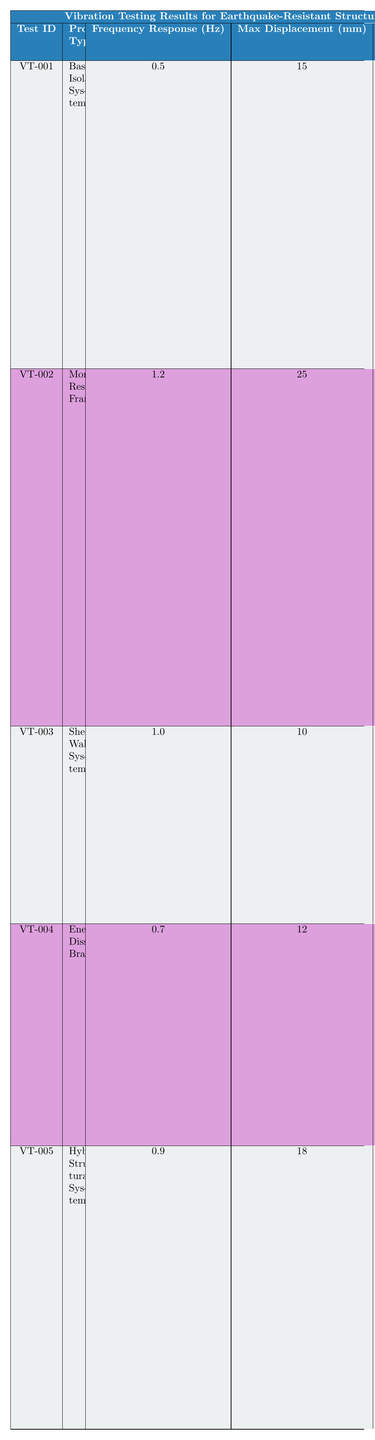What is the maximum displacement recorded for the Base-Isolated System? From the table, the maximum displacement for the Base-Isolated System (Test ID VT-001) is listed as 15 mm.
Answer: 15 mm What was the damping ratio of the Moment-Resisting Frame? According to the table, the Moment-Resisting Frame (Test ID VT-002) has a damping ratio of 0.05.
Answer: 0.05 Is the frequency response of the Shear Wall System greater than that of the Energy-Dissipating Braces? The frequency response for the Shear Wall System (1.0 Hz) is greater than that of the Energy-Dissipating Braces (0.7 Hz), indicating that the statement is true.
Answer: Yes What is the average maximum displacement of all tested systems? The maximum displacements recorded are 15 mm, 25 mm, 10 mm, 12 mm, and 18 mm. Summing them gives (15 + 25 + 10 + 12 + 18) = 80 mm. The average displacement is 80 mm / 5 = 16 mm.
Answer: 16 mm Did all prototypes show a damping ratio of greater than 0.1? Looking at the table, the only prototype with a damping ratio greater than 0.1 is the Base-Isolated System (0.15), while all others are less than or equal to 0.1. Therefore, the statement is false.
Answer: No Which structural system exhibited the highest maximum displacement, and what was that value? The Moment-Resisting Frame (Test ID VT-002) exhibited the highest maximum displacement at 25 mm, as seen in the table under max displacement.
Answer: Moment-Resisting Frame, 25 mm How many prototype types have a damping ratio less than 0.1? The damping ratios are 0.15 (Base-Isolated System), 0.05 (Moment-Resisting Frame), 0.08 (Shear Wall System), 0.12 (Energy-Dissipating Braces), and 0.10 (Hybrid Structural System). The only prototypes with damping ratios less than 0.1 are the Moment-Resisting Frame (0.05) and Shear Wall System (0.08), giving a total of 2.
Answer: 2 What is the frequency response range of the tested prototypes? The frequency responses of the prototypes listed are 0.5 Hz (Base-Isolated System), 1.2 Hz (Moment-Resisting Frame), 1.0 Hz (Shear Wall System), 0.7 Hz (Energy-Dissipating Braces), and 0.9 Hz (Hybrid Structural System). Therefore, the range is from 0.5 Hz to 1.2 Hz.
Answer: 0.5 Hz to 1.2 Hz Which prototype type had the best result in terms of reducing displacement? The Base-Isolated System (Test ID VT-001), with a maximum displacement of 15 mm and significant reduction in displacement results, had the best outcome based on the summary.
Answer: Base-Isolated System 